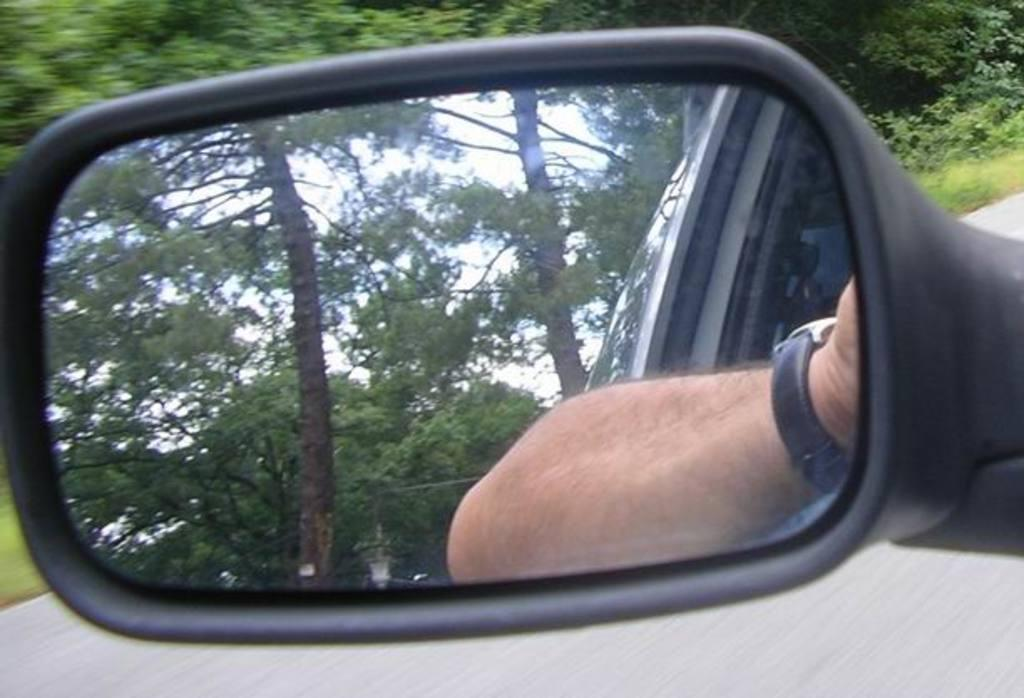What object is the main focus of the image? There is a car mirror in the image. What can be seen in the car mirror? Trees are visible in the car mirror, as well as a man's hand. What is visible in the background of the image? There are trees and a road in the background of the image. What type of pickle is the man holding in the image? There is no pickle present in the image; the man's hand is visible in the car mirror, but no objects are being held. 